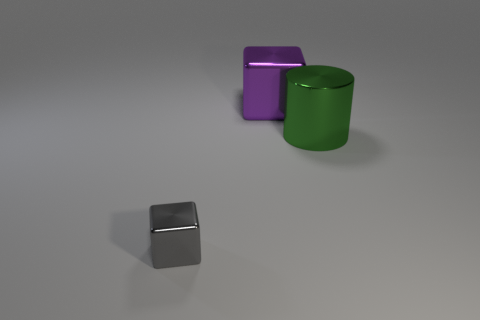How are the different shapes in the image positioned in relation to each other? In the image, the gray cube is positioned closest to the camera, appearing much smaller due to perspective. To the right of it, there's a green cylinder, and directly behind the cylinder stands a larger purple cube. The arrangement suggests a careful placement with an emphasis on depth and perspective to create a sense of dimension in the composition. 